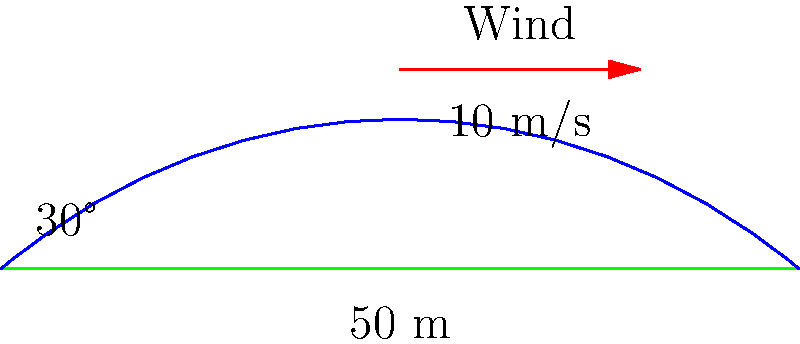A golfer hits a ball from ground level with an initial angle of 30° to the horizontal. The ball travels a total distance of 50 meters. If there is a constant crosswind of 10 m/s perpendicular to the intended direction of the ball, estimate the lateral deviation of the ball from its intended path at the landing point. Assume the ball is in the air for 3 seconds. To solve this problem, we need to follow these steps:

1. Understand the given information:
   - Initial angle: 30°
   - Total distance: 50 meters
   - Crosswind speed: 10 m/s
   - Time in air: 3 seconds

2. Calculate the lateral force on the ball:
   The crosswind will exert a force on the ball, causing it to deviate from its intended path. We can use the equation:

   $F = \frac{1}{2} \rho C_d A v^2$

   Where:
   $\rho$ is the air density (approximately 1.225 kg/m³)
   $C_d$ is the drag coefficient (approximately 0.47 for a golf ball)
   $A$ is the cross-sectional area of the golf ball (approximately 0.001 m²)
   $v$ is the wind velocity (10 m/s)

3. Calculate the acceleration of the ball due to the wind:
   $a = \frac{F}{m}$

   Where $m$ is the mass of a golf ball (approximately 0.0459 kg)

4. Use the equation of motion to calculate the lateral displacement:
   $s = \frac{1}{2} a t^2$

   Where $t$ is the time the ball is in the air (3 seconds)

5. Plug in the values and calculate:

   $F = \frac{1}{2} \times 1.225 \times 0.47 \times 0.001 \times 10^2 = 0.0288$ N

   $a = \frac{0.0288}{0.0459} = 0.627$ m/s²

   $s = \frac{1}{2} \times 0.627 \times 3^2 = 2.82$ m

Therefore, the lateral deviation of the ball at the landing point is approximately 2.82 meters.
Answer: 2.82 meters 